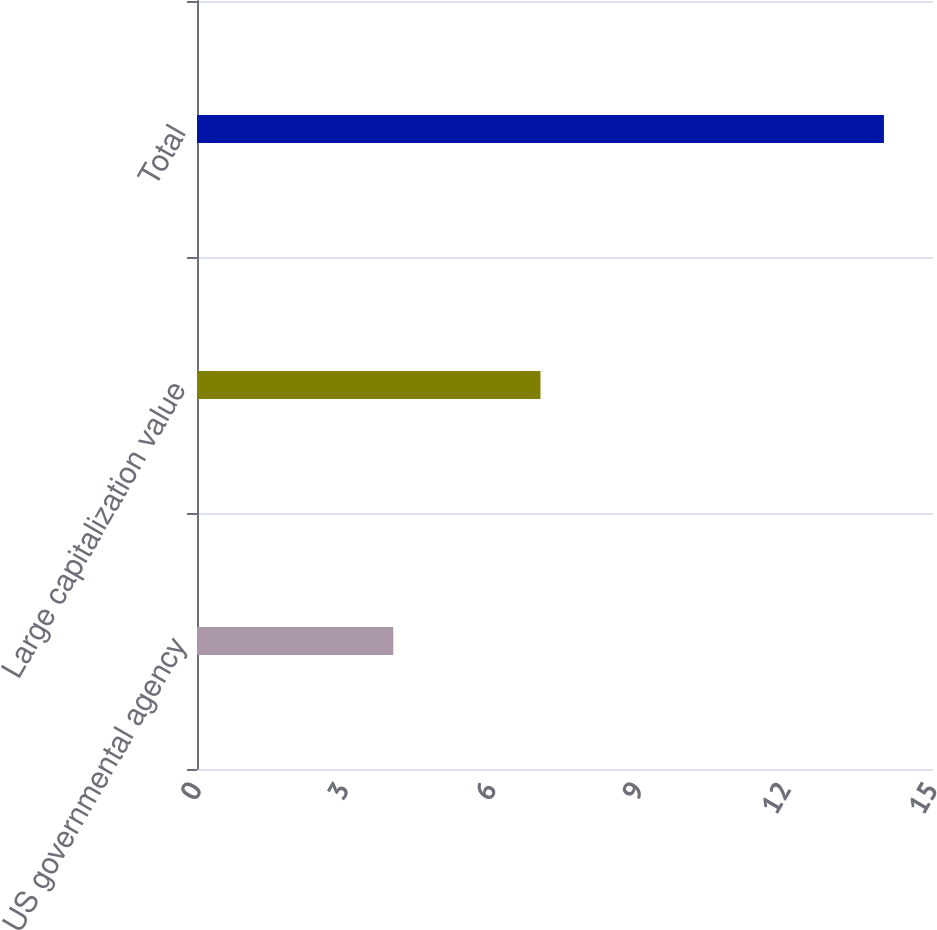Convert chart to OTSL. <chart><loc_0><loc_0><loc_500><loc_500><bar_chart><fcel>US governmental agency<fcel>Large capitalization value<fcel>Total<nl><fcel>4<fcel>7<fcel>14<nl></chart> 